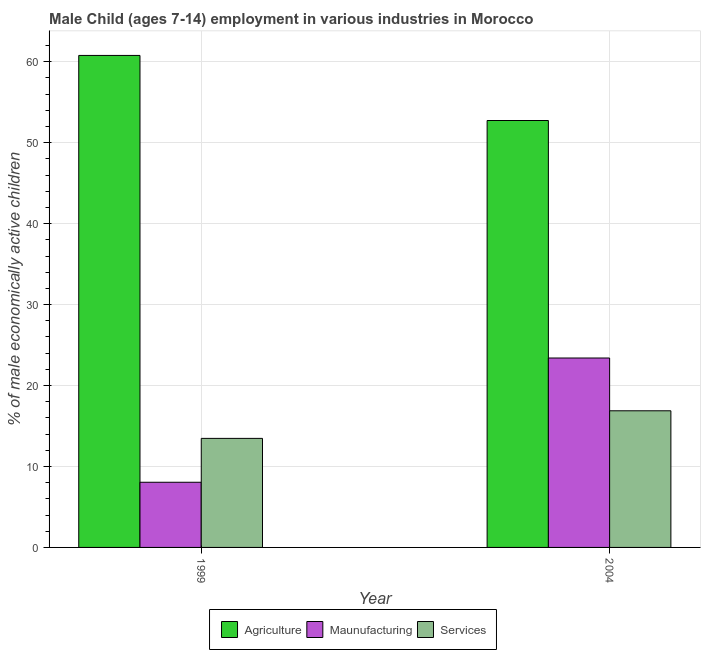Are the number of bars per tick equal to the number of legend labels?
Your answer should be compact. Yes. Are the number of bars on each tick of the X-axis equal?
Your answer should be compact. Yes. What is the label of the 2nd group of bars from the left?
Your answer should be very brief. 2004. What is the percentage of economically active children in agriculture in 2004?
Keep it short and to the point. 52.74. Across all years, what is the maximum percentage of economically active children in manufacturing?
Your answer should be very brief. 23.4. Across all years, what is the minimum percentage of economically active children in manufacturing?
Your answer should be compact. 8.05. In which year was the percentage of economically active children in services maximum?
Give a very brief answer. 2004. What is the total percentage of economically active children in manufacturing in the graph?
Your answer should be very brief. 31.45. What is the difference between the percentage of economically active children in manufacturing in 1999 and that in 2004?
Your answer should be very brief. -15.35. What is the difference between the percentage of economically active children in services in 1999 and the percentage of economically active children in manufacturing in 2004?
Your response must be concise. -3.41. What is the average percentage of economically active children in manufacturing per year?
Your response must be concise. 15.72. In the year 2004, what is the difference between the percentage of economically active children in agriculture and percentage of economically active children in manufacturing?
Your response must be concise. 0. What is the ratio of the percentage of economically active children in agriculture in 1999 to that in 2004?
Provide a succinct answer. 1.15. What does the 3rd bar from the left in 2004 represents?
Provide a succinct answer. Services. What does the 1st bar from the right in 1999 represents?
Provide a succinct answer. Services. Is it the case that in every year, the sum of the percentage of economically active children in agriculture and percentage of economically active children in manufacturing is greater than the percentage of economically active children in services?
Your answer should be very brief. Yes. Are all the bars in the graph horizontal?
Keep it short and to the point. No. How many years are there in the graph?
Offer a terse response. 2. Does the graph contain any zero values?
Your answer should be compact. No. Does the graph contain grids?
Offer a very short reply. Yes. Where does the legend appear in the graph?
Provide a short and direct response. Bottom center. What is the title of the graph?
Your answer should be very brief. Male Child (ages 7-14) employment in various industries in Morocco. What is the label or title of the X-axis?
Provide a short and direct response. Year. What is the label or title of the Y-axis?
Offer a very short reply. % of male economically active children. What is the % of male economically active children of Agriculture in 1999?
Provide a succinct answer. 60.78. What is the % of male economically active children of Maunufacturing in 1999?
Offer a very short reply. 8.05. What is the % of male economically active children of Services in 1999?
Give a very brief answer. 13.47. What is the % of male economically active children in Agriculture in 2004?
Offer a very short reply. 52.74. What is the % of male economically active children in Maunufacturing in 2004?
Keep it short and to the point. 23.4. What is the % of male economically active children of Services in 2004?
Your response must be concise. 16.88. Across all years, what is the maximum % of male economically active children in Agriculture?
Your answer should be compact. 60.78. Across all years, what is the maximum % of male economically active children in Maunufacturing?
Your response must be concise. 23.4. Across all years, what is the maximum % of male economically active children of Services?
Provide a short and direct response. 16.88. Across all years, what is the minimum % of male economically active children of Agriculture?
Offer a very short reply. 52.74. Across all years, what is the minimum % of male economically active children in Maunufacturing?
Ensure brevity in your answer.  8.05. Across all years, what is the minimum % of male economically active children in Services?
Offer a very short reply. 13.47. What is the total % of male economically active children of Agriculture in the graph?
Your response must be concise. 113.52. What is the total % of male economically active children in Maunufacturing in the graph?
Give a very brief answer. 31.45. What is the total % of male economically active children of Services in the graph?
Your answer should be compact. 30.35. What is the difference between the % of male economically active children in Agriculture in 1999 and that in 2004?
Keep it short and to the point. 8.04. What is the difference between the % of male economically active children of Maunufacturing in 1999 and that in 2004?
Make the answer very short. -15.35. What is the difference between the % of male economically active children in Services in 1999 and that in 2004?
Give a very brief answer. -3.41. What is the difference between the % of male economically active children of Agriculture in 1999 and the % of male economically active children of Maunufacturing in 2004?
Make the answer very short. 37.38. What is the difference between the % of male economically active children of Agriculture in 1999 and the % of male economically active children of Services in 2004?
Offer a very short reply. 43.9. What is the difference between the % of male economically active children in Maunufacturing in 1999 and the % of male economically active children in Services in 2004?
Ensure brevity in your answer.  -8.83. What is the average % of male economically active children of Agriculture per year?
Offer a very short reply. 56.76. What is the average % of male economically active children in Maunufacturing per year?
Provide a succinct answer. 15.72. What is the average % of male economically active children in Services per year?
Your response must be concise. 15.18. In the year 1999, what is the difference between the % of male economically active children in Agriculture and % of male economically active children in Maunufacturing?
Provide a short and direct response. 52.73. In the year 1999, what is the difference between the % of male economically active children in Agriculture and % of male economically active children in Services?
Your answer should be very brief. 47.31. In the year 1999, what is the difference between the % of male economically active children of Maunufacturing and % of male economically active children of Services?
Offer a very short reply. -5.42. In the year 2004, what is the difference between the % of male economically active children in Agriculture and % of male economically active children in Maunufacturing?
Provide a succinct answer. 29.34. In the year 2004, what is the difference between the % of male economically active children of Agriculture and % of male economically active children of Services?
Keep it short and to the point. 35.86. In the year 2004, what is the difference between the % of male economically active children of Maunufacturing and % of male economically active children of Services?
Make the answer very short. 6.52. What is the ratio of the % of male economically active children of Agriculture in 1999 to that in 2004?
Your answer should be very brief. 1.15. What is the ratio of the % of male economically active children of Maunufacturing in 1999 to that in 2004?
Provide a succinct answer. 0.34. What is the ratio of the % of male economically active children in Services in 1999 to that in 2004?
Offer a very short reply. 0.8. What is the difference between the highest and the second highest % of male economically active children of Agriculture?
Your answer should be very brief. 8.04. What is the difference between the highest and the second highest % of male economically active children in Maunufacturing?
Keep it short and to the point. 15.35. What is the difference between the highest and the second highest % of male economically active children of Services?
Your answer should be very brief. 3.41. What is the difference between the highest and the lowest % of male economically active children of Agriculture?
Your answer should be very brief. 8.04. What is the difference between the highest and the lowest % of male economically active children in Maunufacturing?
Ensure brevity in your answer.  15.35. What is the difference between the highest and the lowest % of male economically active children of Services?
Give a very brief answer. 3.41. 